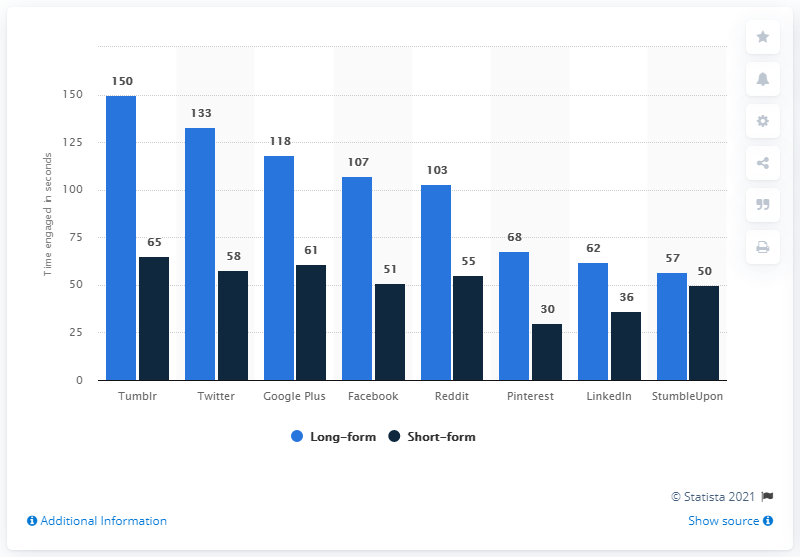Mention a couple of crucial points in this snapshot. The ratio of time spent on short-form Pinterest compared to short-form StumbleUpon news articles is 0.6. The average time spent engaging with a Facebook news article in the short-form format is approximately 51 seconds. 